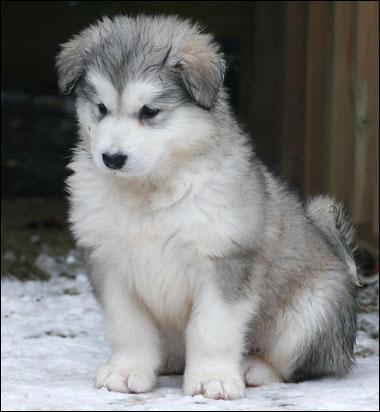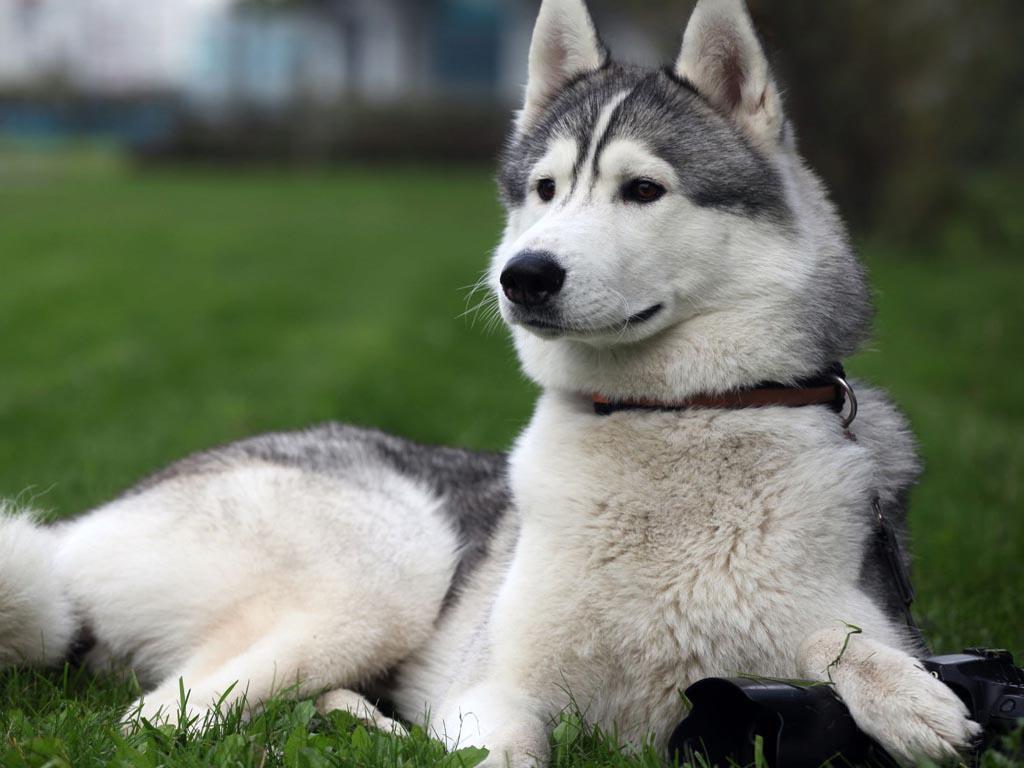The first image is the image on the left, the second image is the image on the right. Analyze the images presented: Is the assertion "The left image contains a puppy with forward-flopped ears, and the right image contains an adult dog with a closed mouth and non-blue eyes." valid? Answer yes or no. Yes. The first image is the image on the left, the second image is the image on the right. For the images shown, is this caption "One dog is laying down." true? Answer yes or no. Yes. 